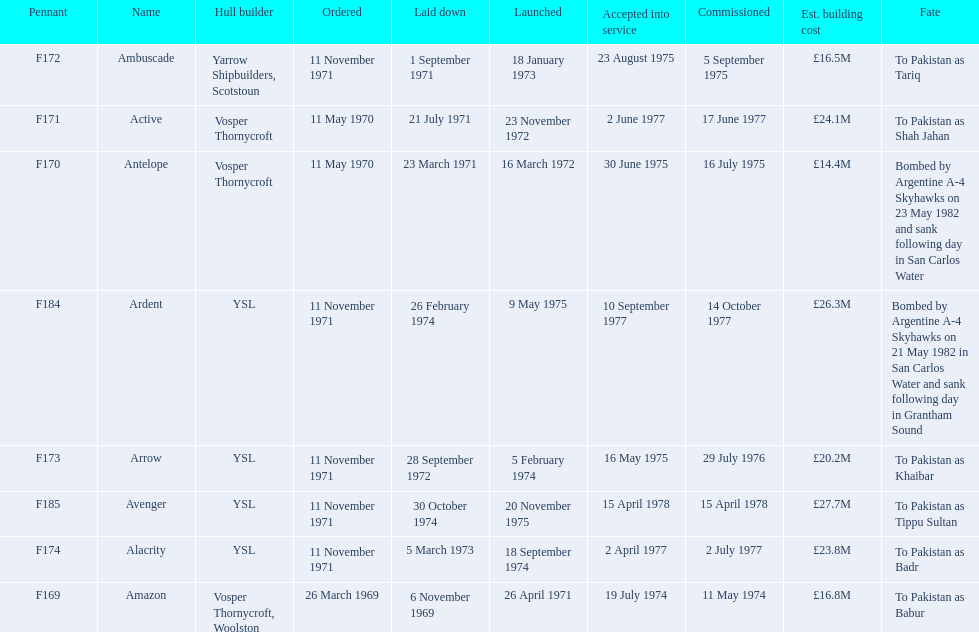Which type 21 frigate ships were to be built by ysl in the 1970s? Arrow, Alacrity, Ardent, Avenger. Of these ships, which one had the highest estimated building cost? Avenger. 